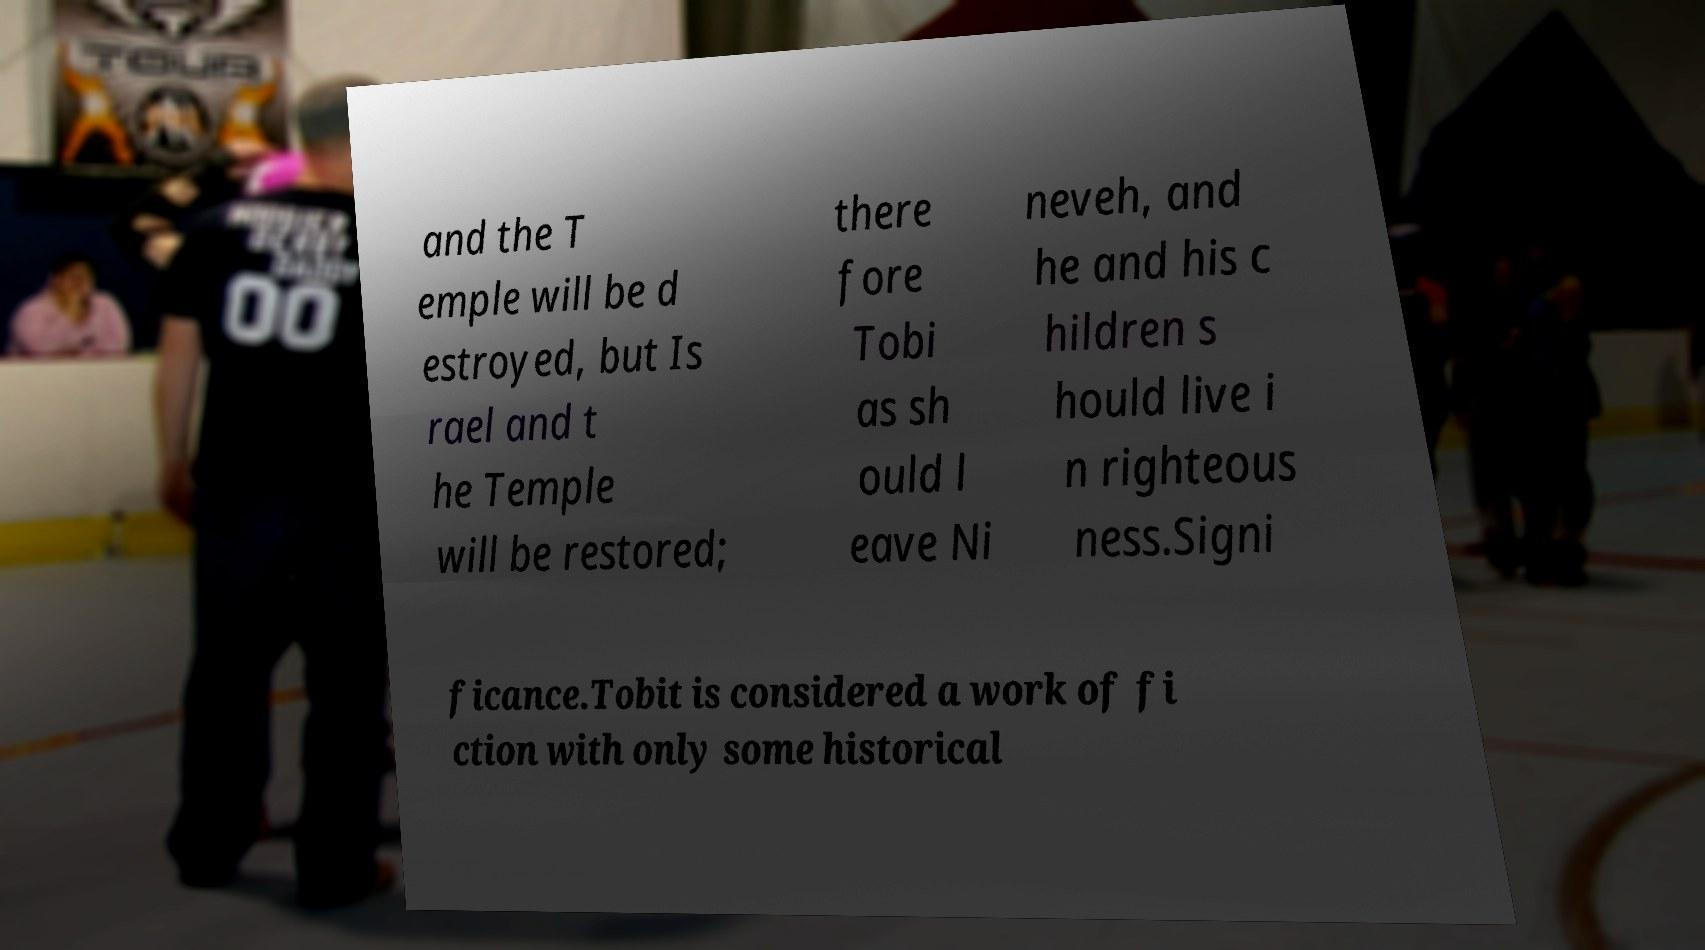Could you extract and type out the text from this image? and the T emple will be d estroyed, but Is rael and t he Temple will be restored; there fore Tobi as sh ould l eave Ni neveh, and he and his c hildren s hould live i n righteous ness.Signi ficance.Tobit is considered a work of fi ction with only some historical 